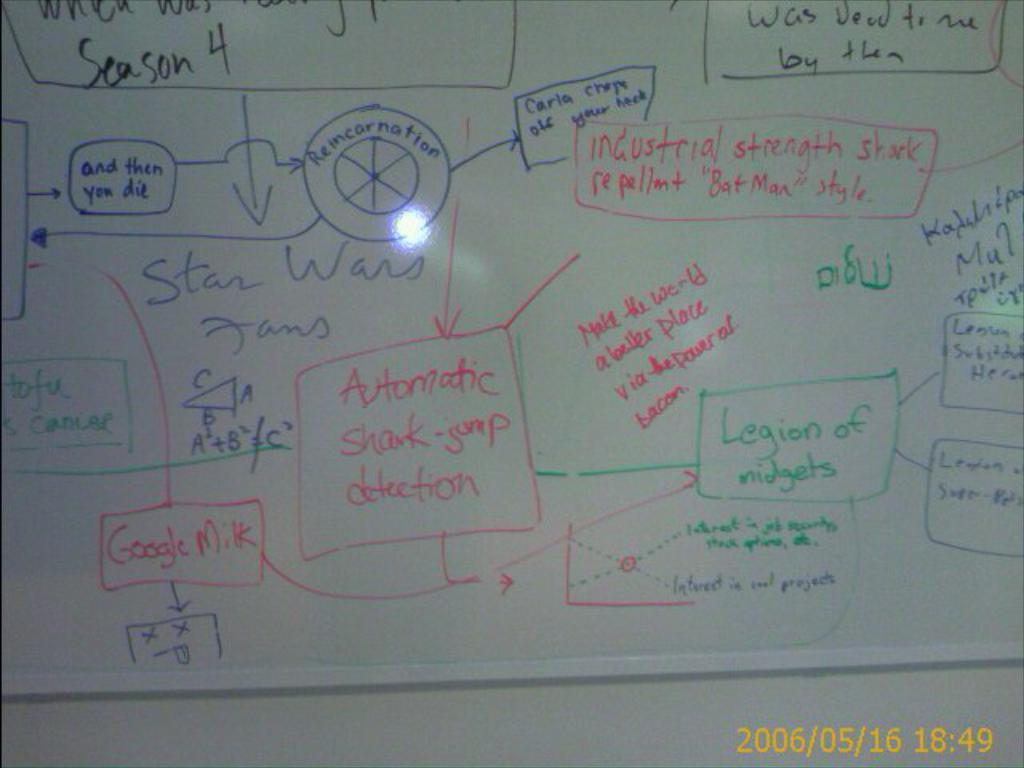<image>
Summarize the visual content of the image. A whiteboard contains many scribbled messages, such as "Automatic shark-jump detection" and "Legion of midgets". 